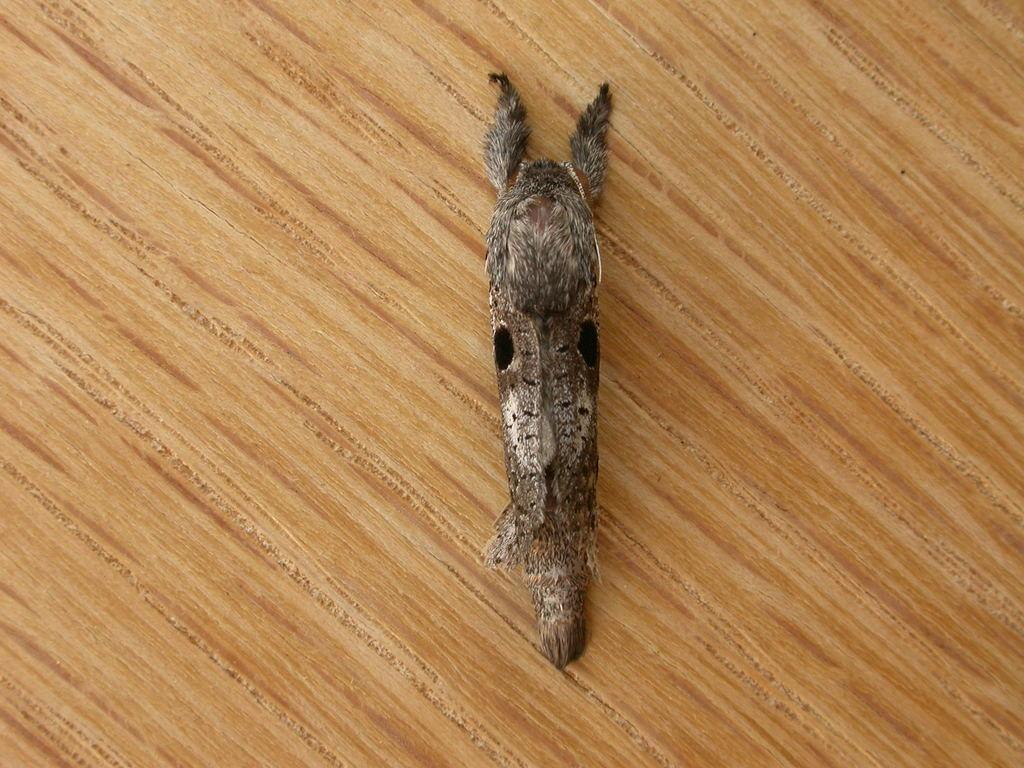How would you summarize this image in a sentence or two? In the picture I can see an insect on the wooden block. 